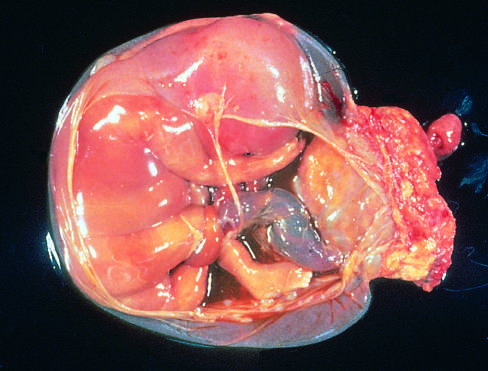what extends from the portion of the amniotic sac to encircle the leg of the fetus?
Answer the question using a single word or phrase. The band of amnion 